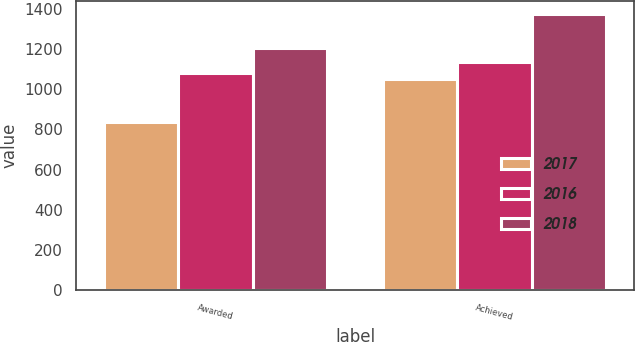Convert chart. <chart><loc_0><loc_0><loc_500><loc_500><stacked_bar_chart><ecel><fcel>Awarded<fcel>Achieved<nl><fcel>2017<fcel>837<fcel>1050<nl><fcel>2016<fcel>1082<fcel>1135<nl><fcel>2018<fcel>1206<fcel>1373<nl></chart> 